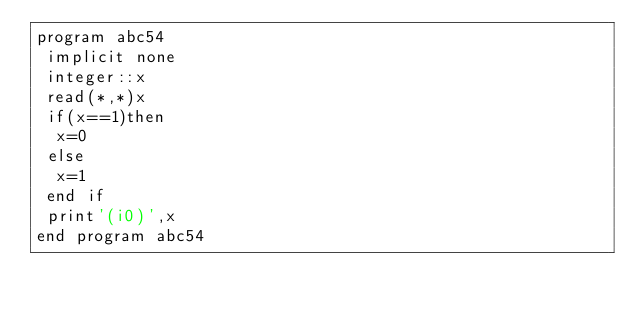<code> <loc_0><loc_0><loc_500><loc_500><_FORTRAN_>program abc54
 implicit none
 integer::x
 read(*,*)x
 if(x==1)then
  x=0
 else
  x=1
 end if
 print'(i0)',x
end program abc54</code> 